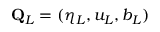Convert formula to latex. <formula><loc_0><loc_0><loc_500><loc_500>Q _ { L } = ( \eta _ { L } , u _ { L } , b _ { L } )</formula> 